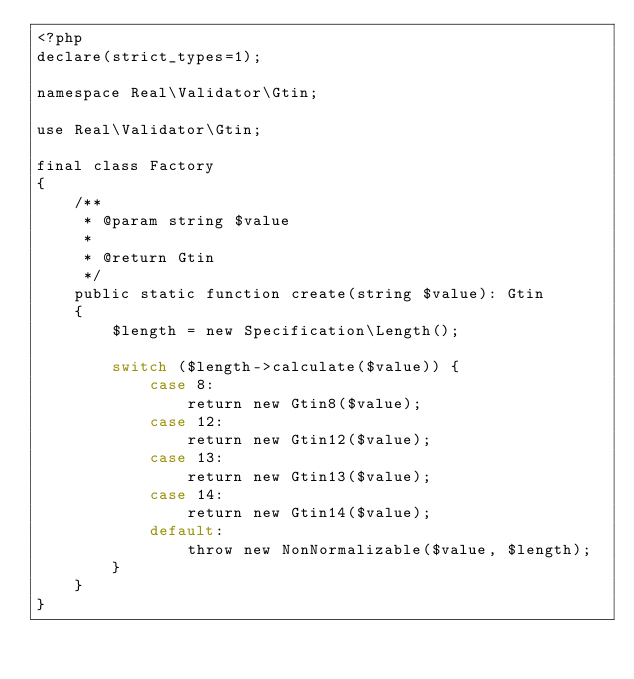Convert code to text. <code><loc_0><loc_0><loc_500><loc_500><_PHP_><?php
declare(strict_types=1);

namespace Real\Validator\Gtin;

use Real\Validator\Gtin;

final class Factory
{
    /**
     * @param string $value
     *
     * @return Gtin
     */
    public static function create(string $value): Gtin
    {
        $length = new Specification\Length();

        switch ($length->calculate($value)) {
            case 8:
                return new Gtin8($value);
            case 12:
                return new Gtin12($value);
            case 13:
                return new Gtin13($value);
            case 14:
                return new Gtin14($value);
            default:
                throw new NonNormalizable($value, $length);
        }
    }
}
</code> 